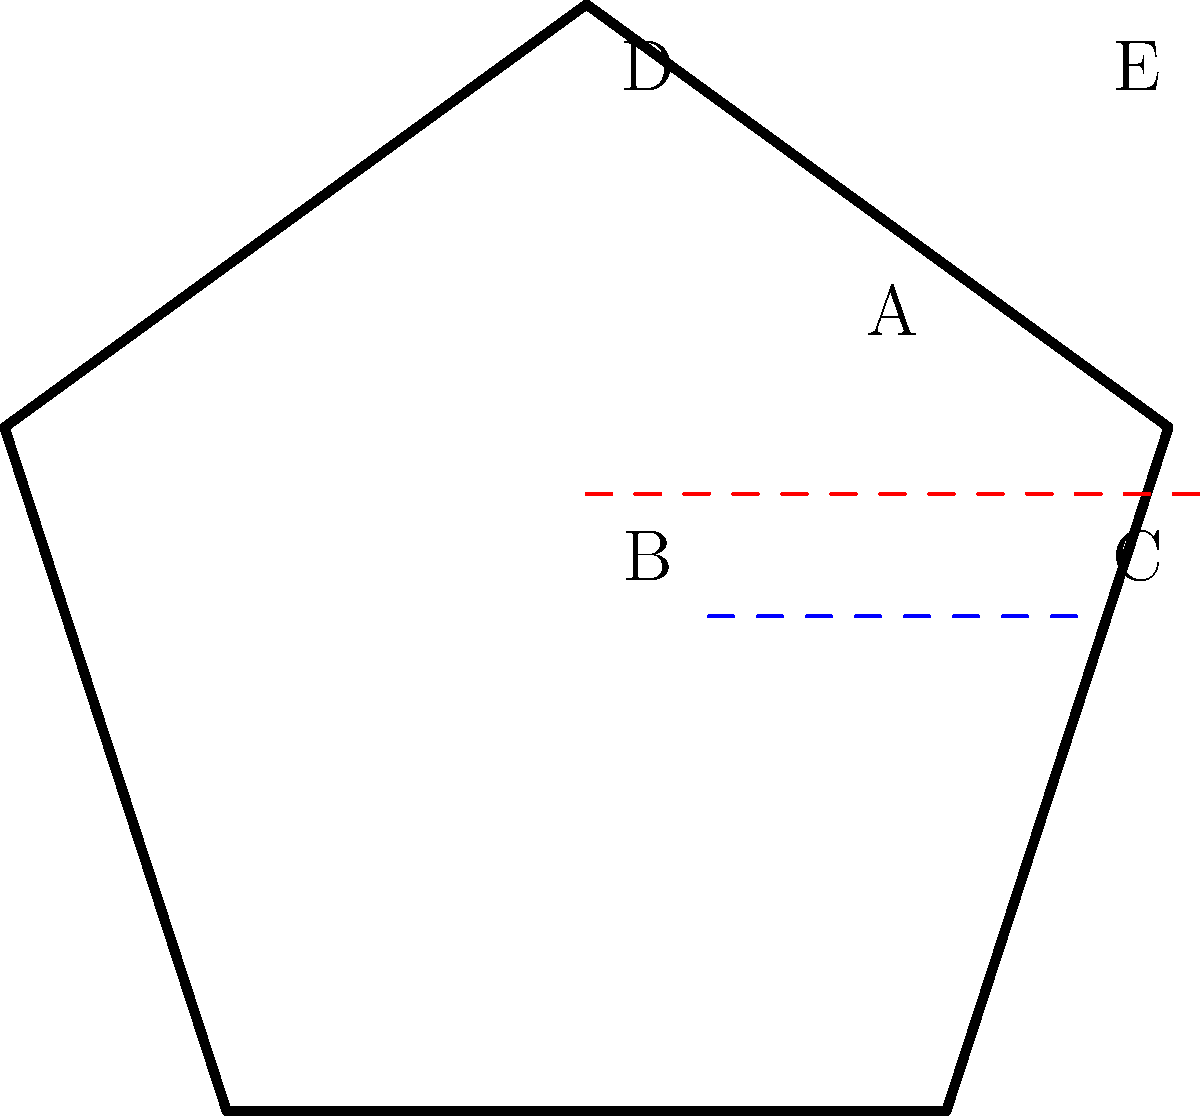In a Taekwondo uniform (dobok) folding sequence, the uniform is first folded along the blue dashed line, then along the red dashed line. Which point will be on top after these folds? Let's follow the folding sequence step-by-step:

1. The blue dashed line represents the first fold. This fold will bring point C up to align with point B, while point E will align with point D.

2. After the first fold, the pentagon shape will be reduced to a trapezoid, with points B and C at the bottom, and points D and E at the top.

3. The red dashed line represents the second fold. This fold will bring the bottom part (including points B and C) up towards the top.

4. When we complete the second fold, point A will remain in its original position, while points B and C will be folded over points D and E respectively.

5. Since point C was initially at the bottom right and is being folded over twice, it will end up on the very top after both folds are completed.

Therefore, point C will be on top after these folds.
Answer: C 